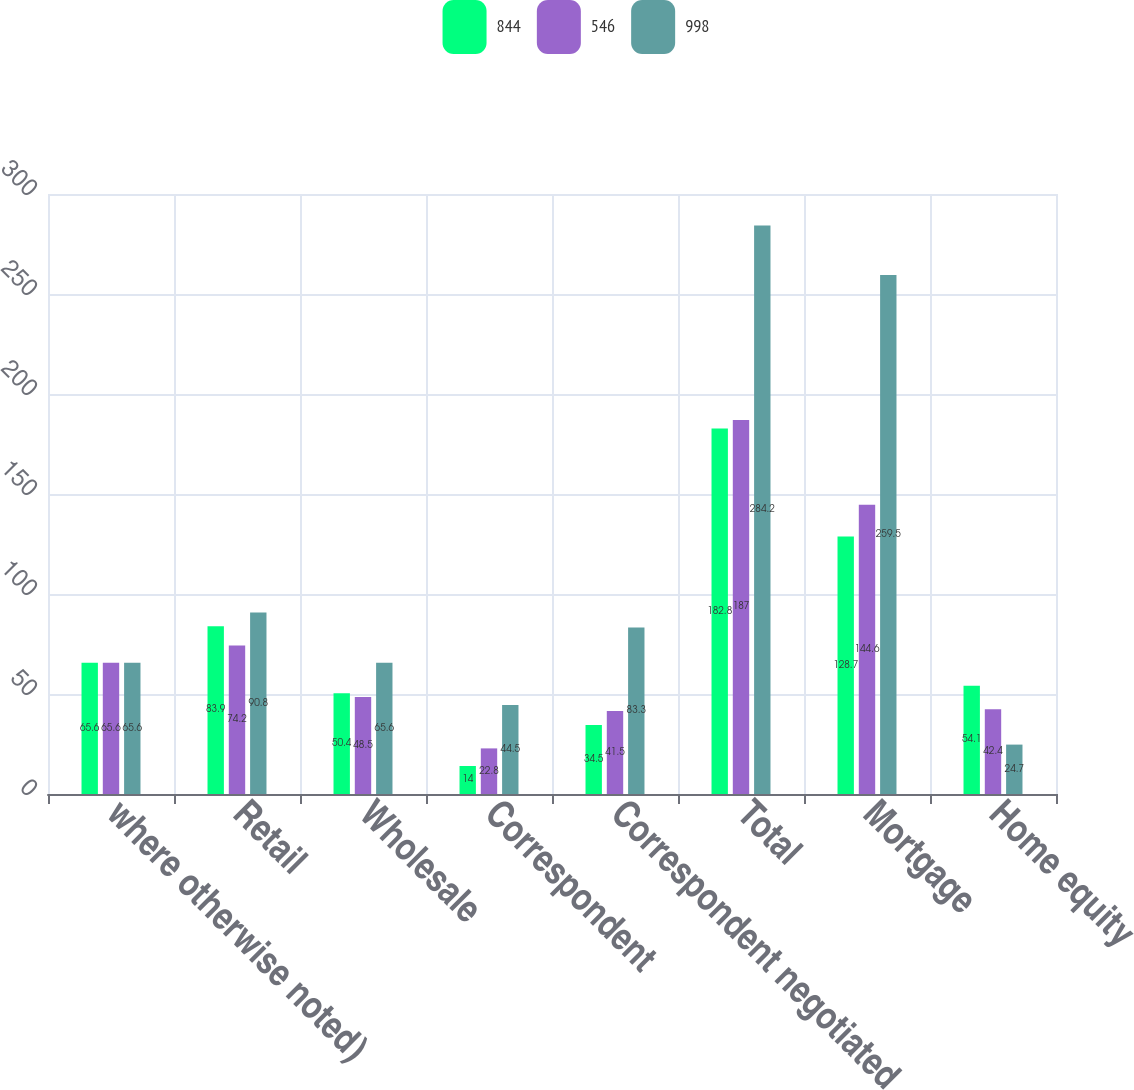<chart> <loc_0><loc_0><loc_500><loc_500><stacked_bar_chart><ecel><fcel>where otherwise noted)<fcel>Retail<fcel>Wholesale<fcel>Correspondent<fcel>Correspondent negotiated<fcel>Total<fcel>Mortgage<fcel>Home equity<nl><fcel>844<fcel>65.6<fcel>83.9<fcel>50.4<fcel>14<fcel>34.5<fcel>182.8<fcel>128.7<fcel>54.1<nl><fcel>546<fcel>65.6<fcel>74.2<fcel>48.5<fcel>22.8<fcel>41.5<fcel>187<fcel>144.6<fcel>42.4<nl><fcel>998<fcel>65.6<fcel>90.8<fcel>65.6<fcel>44.5<fcel>83.3<fcel>284.2<fcel>259.5<fcel>24.7<nl></chart> 